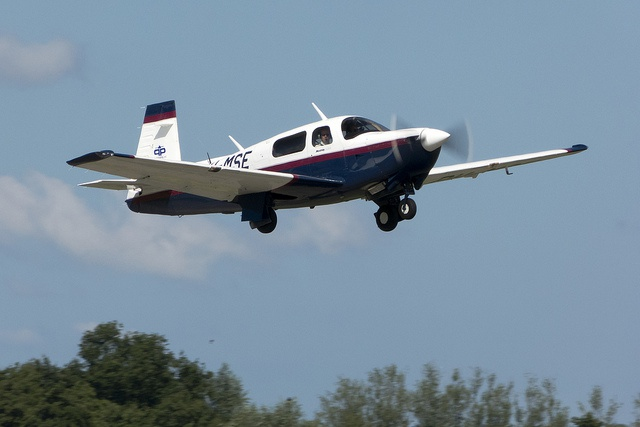Describe the objects in this image and their specific colors. I can see airplane in darkgray, black, gray, and white tones, people in black, gray, and darkgray tones, and people in darkgray, black, and gray tones in this image. 